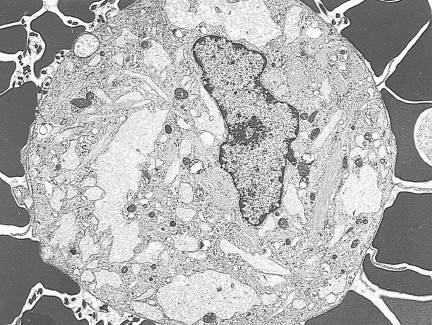s electron micrograph of gaucher cells with elongated distended lysosomes?
Answer the question using a single word or phrase. Yes 